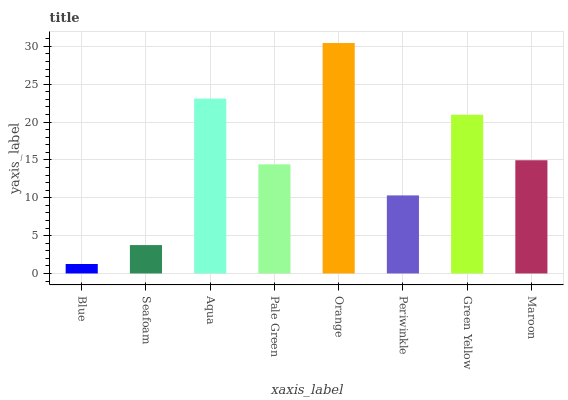Is Blue the minimum?
Answer yes or no. Yes. Is Orange the maximum?
Answer yes or no. Yes. Is Seafoam the minimum?
Answer yes or no. No. Is Seafoam the maximum?
Answer yes or no. No. Is Seafoam greater than Blue?
Answer yes or no. Yes. Is Blue less than Seafoam?
Answer yes or no. Yes. Is Blue greater than Seafoam?
Answer yes or no. No. Is Seafoam less than Blue?
Answer yes or no. No. Is Maroon the high median?
Answer yes or no. Yes. Is Pale Green the low median?
Answer yes or no. Yes. Is Blue the high median?
Answer yes or no. No. Is Orange the low median?
Answer yes or no. No. 